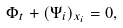<formula> <loc_0><loc_0><loc_500><loc_500>\Phi _ { t } + ( \Psi _ { i } ) _ { x _ { i } } = 0 ,</formula> 